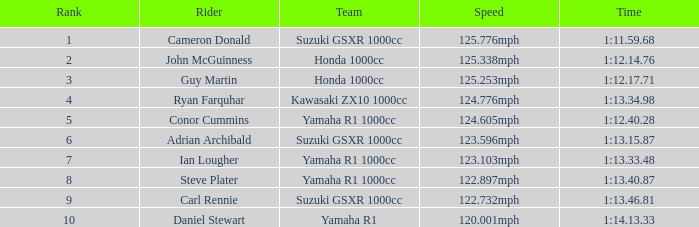What was the time recorded by team kawasaki zx10 1000cc? 1:13.34.98. Could you parse the entire table? {'header': ['Rank', 'Rider', 'Team', 'Speed', 'Time'], 'rows': [['1', 'Cameron Donald', 'Suzuki GSXR 1000cc', '125.776mph', '1:11.59.68'], ['2', 'John McGuinness', 'Honda 1000cc', '125.338mph', '1:12.14.76'], ['3', 'Guy Martin', 'Honda 1000cc', '125.253mph', '1:12.17.71'], ['4', 'Ryan Farquhar', 'Kawasaki ZX10 1000cc', '124.776mph', '1:13.34.98'], ['5', 'Conor Cummins', 'Yamaha R1 1000cc', '124.605mph', '1:12.40.28'], ['6', 'Adrian Archibald', 'Suzuki GSXR 1000cc', '123.596mph', '1:13.15.87'], ['7', 'Ian Lougher', 'Yamaha R1 1000cc', '123.103mph', '1:13.33.48'], ['8', 'Steve Plater', 'Yamaha R1 1000cc', '122.897mph', '1:13.40.87'], ['9', 'Carl Rennie', 'Suzuki GSXR 1000cc', '122.732mph', '1:13.46.81'], ['10', 'Daniel Stewart', 'Yamaha R1', '120.001mph', '1:14.13.33']]} 